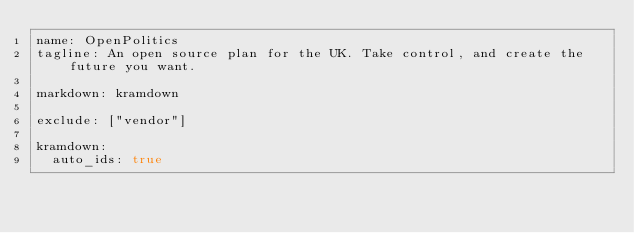<code> <loc_0><loc_0><loc_500><loc_500><_YAML_>name: OpenPolitics
tagline: An open source plan for the UK. Take control, and create the future you want.

markdown: kramdown

exclude: ["vendor"]

kramdown:
  auto_ids: true
</code> 